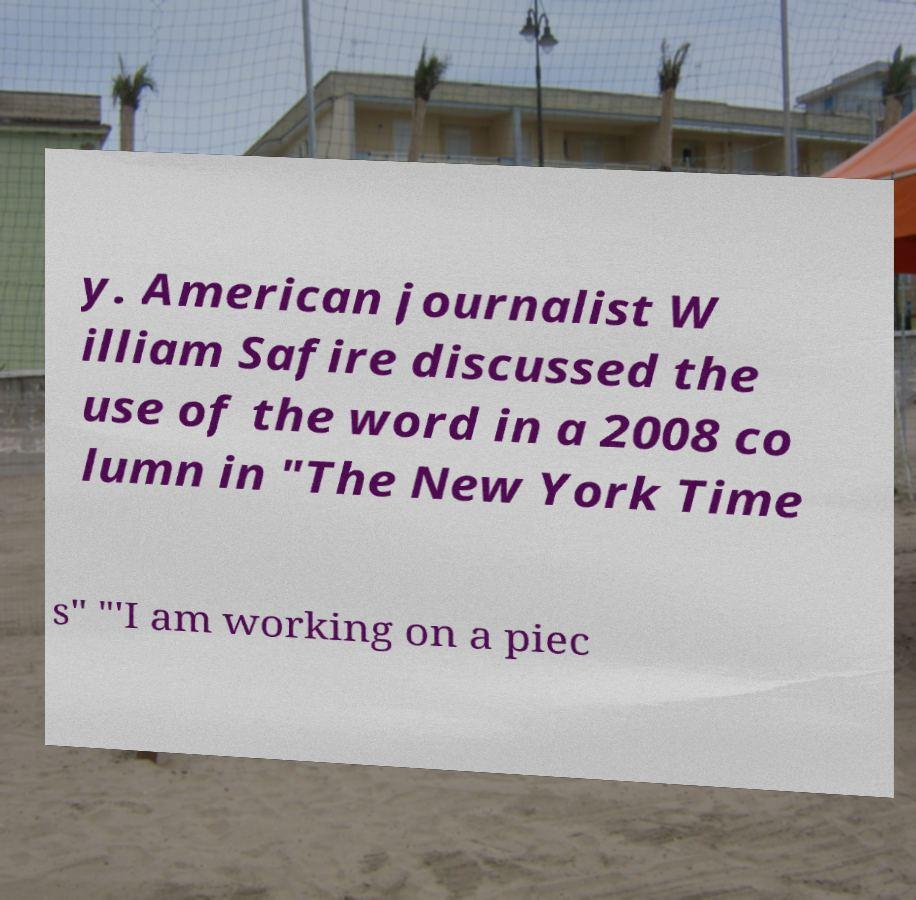There's text embedded in this image that I need extracted. Can you transcribe it verbatim? y. American journalist W illiam Safire discussed the use of the word in a 2008 co lumn in "The New York Time s" "'I am working on a piec 